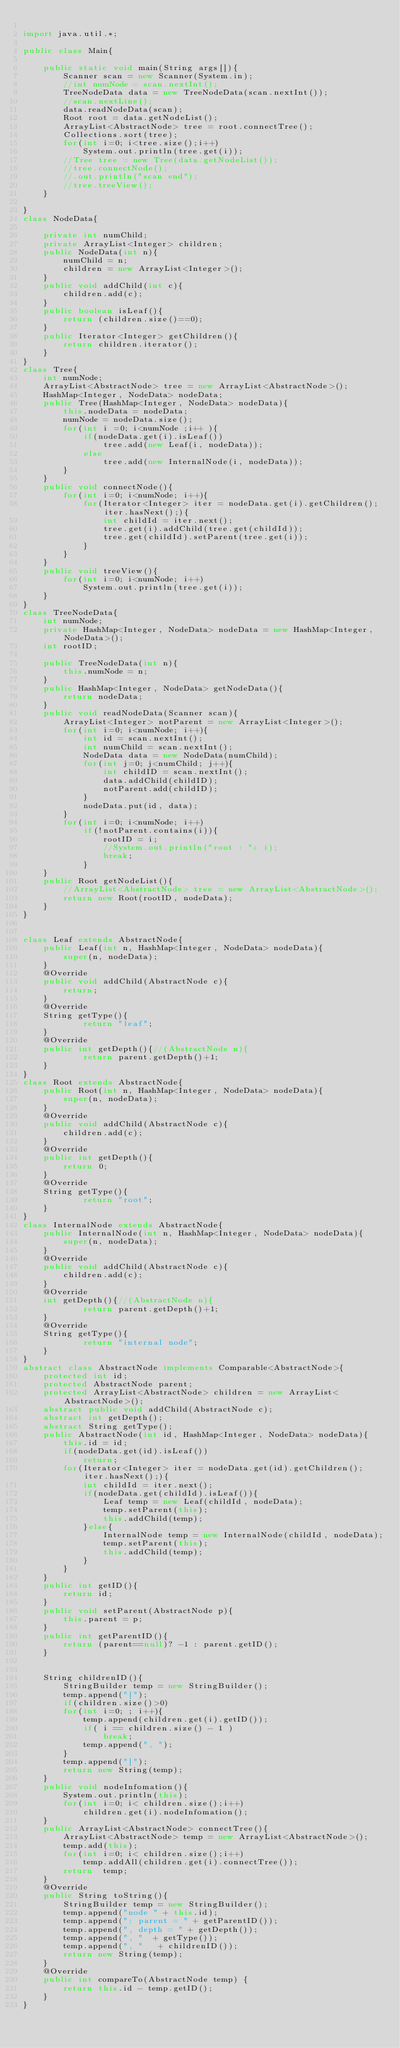Convert code to text. <code><loc_0><loc_0><loc_500><loc_500><_Java_>
import java.util.*;

public class Main{ 

	public static void main(String args[]){
		Scanner scan = new Scanner(System.in);
		//int numNode = scan.nextInt();
		TreeNodeData data = new TreeNodeData(scan.nextInt());
		//scan.nextLine();
		data.readNodeData(scan);
		Root root = data.getNodeList();
		ArrayList<AbstractNode> tree = root.connectTree();
		Collections.sort(tree);
		for(int i=0; i<tree.size();i++)
			System.out.println(tree.get(i));
		//Tree tree = new Tree(data.getNodeList());
		//tree.connectNode();
		//.out.println("scan end");
		//tree.treeView();
	}

}
class NodeData{

	private int numChild;
	private ArrayList<Integer> children;
	public NodeData(int n){
		numChild = n;
		children = new ArrayList<Integer>();
	}
	public void addChild(int c){
		children.add(c);
	}
	public boolean isLeaf(){
		return (children.size()==0);
	}
	public Iterator<Integer> getChildren(){
		return children.iterator();
	}
}
class Tree{
	int numNode;
	ArrayList<AbstractNode> tree = new ArrayList<AbstractNode>();
	HashMap<Integer, NodeData> nodeData;
	public Tree(HashMap<Integer, NodeData> nodeData){
		this.nodeData = nodeData;
		numNode = nodeData.size();
		for(int i =0; i<numNode ;i++ ){
			if(nodeData.get(i).isLeaf())
				tree.add(new Leaf(i, nodeData));
			else
				tree.add(new InternalNode(i, nodeData));
		}
	}
	public void connectNode(){
		for(int i=0; i<numNode; i++){
			for(Iterator<Integer> iter = nodeData.get(i).getChildren(); iter.hasNext();){
				int childId = iter.next();
				tree.get(i).addChild(tree.get(childId));
				tree.get(childId).setParent(tree.get(i));
			}
		}
	}
	public void treeView(){
		for(int i=0; i<numNode; i++)
			System.out.println(tree.get(i));
	}
}
class TreeNodeData{
	int numNode;
	private HashMap<Integer, NodeData> nodeData = new HashMap<Integer, NodeData>();
	int rootID;

	public TreeNodeData(int n){
		this.numNode = n;	
	}
	public HashMap<Integer, NodeData> getNodeData(){
		return nodeData;
	}
	public void readNodeData(Scanner scan){
		ArrayList<Integer> notParent = new ArrayList<Integer>();
		for(int i=0; i<numNode; i++){
			int id = scan.nextInt();
			int numChild = scan.nextInt();
			NodeData data = new NodeData(numChild);
			for(int j=0; j<numChild; j++){
				int childID = scan.nextInt();
				data.addChild(childID);
				notParent.add(childID);
			}
			nodeData.put(id, data);
		}
		for(int i=0; i<numNode; i++)
			if(!notParent.contains(i)){
				rootID = i;
				//System.out.println("root : "+ i);
				break;
			}
	}
	public Root getNodeList(){
		//ArrayList<AbstractNode> tree = new ArrayList<AbstractNode>();
		return new Root(rootID, nodeData);	
	}
}


class Leaf extends AbstractNode{
	public Leaf(int n, HashMap<Integer, NodeData> nodeData){
		super(n, nodeData);
	}
	@Override 
	public void addChild(AbstractNode c){
		return;
	}
	@Override 
	String getType(){
			return "leaf";
	}
	@Override 
	public int getDepth(){//(AbstractNode n){
			return parent.getDepth()+1;
	}
}
class Root extends AbstractNode{
	public Root(int n, HashMap<Integer, NodeData> nodeData){
		super(n, nodeData);
	}
	@Override 
	public void addChild(AbstractNode c){
		children.add(c);
	}
	@Override 
	public int getDepth(){
		return 0;
	}
	@Override 
	String getType(){
			return "root";
	}
}
class InternalNode extends AbstractNode{
	public InternalNode(int n, HashMap<Integer, NodeData> nodeData){
		super(n, nodeData);
	}
	@Override 
	public void addChild(AbstractNode c){
		children.add(c);
	}
	@Override 
	int getDepth(){//(AbstractNode n){
			return parent.getDepth()+1;
	}
	@Override 
	String getType(){
			return "internal node";
	}
}
abstract class AbstractNode implements Comparable<AbstractNode>{
	protected int id;
	protected AbstractNode parent;
	protected ArrayList<AbstractNode> children = new ArrayList<AbstractNode>();
	abstract public void addChild(AbstractNode c);
	abstract int getDepth();
	abstract String getType();
	public AbstractNode(int id, HashMap<Integer, NodeData> nodeData){
		this.id = id;
		if(nodeData.get(id).isLeaf())
			return;
		for(Iterator<Integer> iter = nodeData.get(id).getChildren(); iter.hasNext();){
			int childId = iter.next();
			if(nodeData.get(childId).isLeaf()){
				Leaf temp = new Leaf(childId, nodeData);
				temp.setParent(this);
				this.addChild(temp);
			}else{
				InternalNode temp = new InternalNode(childId, nodeData);
				temp.setParent(this);
				this.addChild(temp);
			}
		}
	}
	public int getID(){
		return id;
	}
	public void setParent(AbstractNode p){
		this.parent = p;
	}
	public int getParentID(){
		return (parent==null)? -1 : parent.getID();
	}


	String childrenID(){
		StringBuilder temp = new StringBuilder();
		temp.append("[");
		if(children.size()>0)
		for(int i=0; ; i++){
			temp.append(children.get(i).getID());
			if( i == children.size() - 1 )
				break;
			temp.append(", ");
		}
		temp.append("]");
		return new String(temp);
	}
	public void nodeInfomation(){
		System.out.println(this);
		for(int i=0; i< children.size();i++)
			children.get(i).nodeInfomation();
	}
	public ArrayList<AbstractNode> connectTree(){
		ArrayList<AbstractNode> temp = new ArrayList<AbstractNode>();
		temp.add(this);
		for(int i=0; i< children.size();i++)
			temp.addAll(children.get(i).connectTree());
		return 	temp;
	}
	@Override
	public String toString(){
		StringBuilder temp = new StringBuilder();
		temp.append("node " + this.id);
		temp.append(": parent = " + getParentID());
		temp.append(", depth = " + getDepth());
		temp.append(", "  + getType());
		temp.append(", "   + childrenID());
		return new String(temp);
	}
	@Override
 	public int compareTo(AbstractNode temp) {
		return this.id - temp.getID();
	}
}</code> 